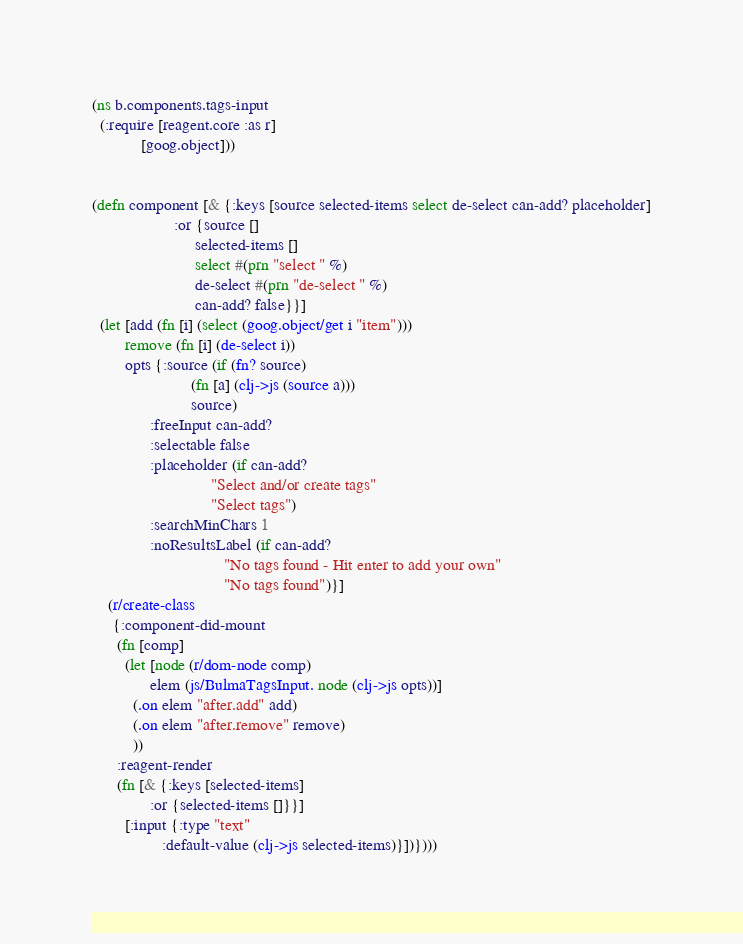Convert code to text. <code><loc_0><loc_0><loc_500><loc_500><_Clojure_>(ns b.components.tags-input
  (:require [reagent.core :as r]
            [goog.object]))


(defn component [& {:keys [source selected-items select de-select can-add? placeholder]
                    :or {source []
                         selected-items []
                         select #(prn "select " %)
                         de-select #(prn "de-select " %)
                         can-add? false}}]
  (let [add (fn [i] (select (goog.object/get i "item")))
        remove (fn [i] (de-select i))
        opts {:source (if (fn? source)
                        (fn [a] (clj->js (source a)))
                        source)
              :freeInput can-add?
              :selectable false
              :placeholder (if can-add?
                             "Select and/or create tags"
                             "Select tags")
              :searchMinChars 1
              :noResultsLabel (if can-add?
                                "No tags found - Hit enter to add your own"
                                "No tags found")}]
    (r/create-class
     {:component-did-mount
      (fn [comp]
        (let [node (r/dom-node comp)
              elem (js/BulmaTagsInput. node (clj->js opts))]
          (.on elem "after.add" add)
          (.on elem "after.remove" remove)
          ))
      :reagent-render
      (fn [& {:keys [selected-items]
              :or {selected-items []}}]
        [:input {:type "text"
                 :default-value (clj->js selected-items)}])})))
</code> 